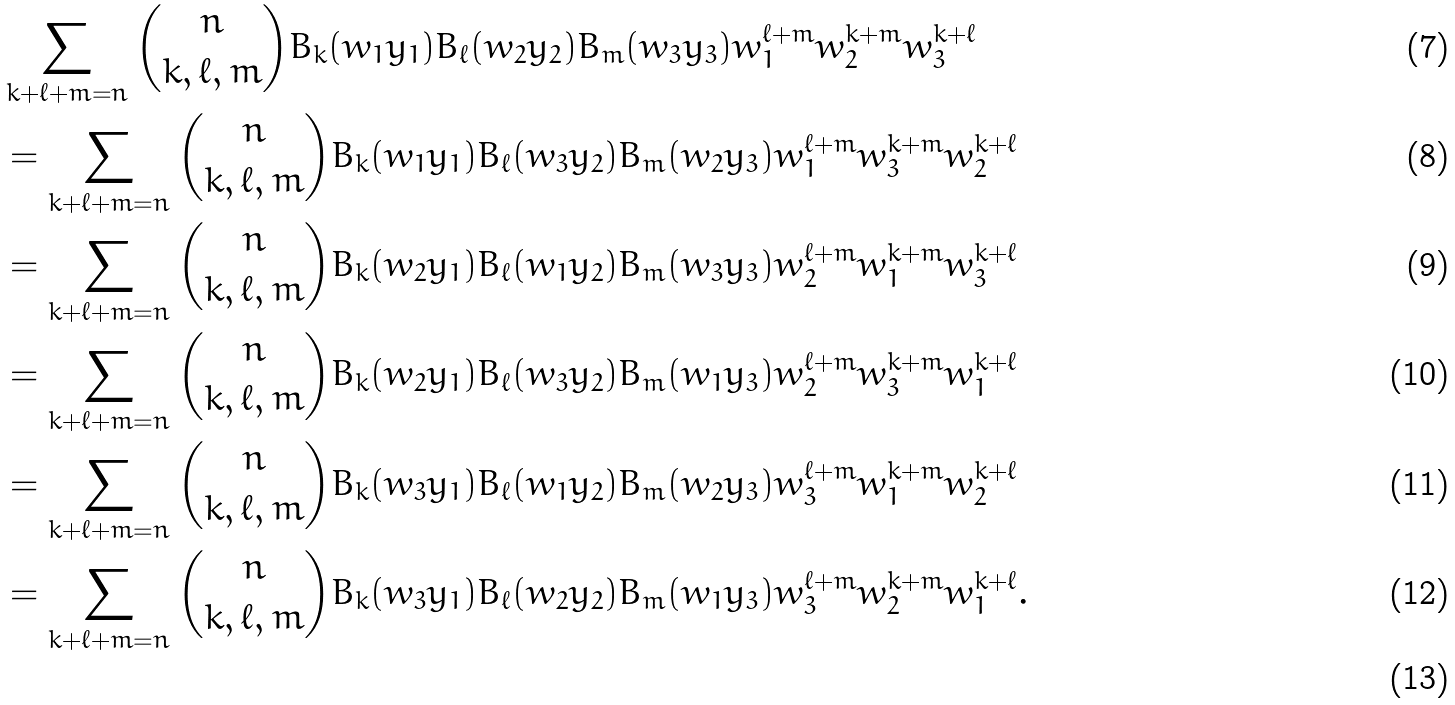Convert formula to latex. <formula><loc_0><loc_0><loc_500><loc_500>& \sum _ { k + \ell + m = n } \binom { n } { k , \ell , m } B _ { k } ( w _ { 1 } y _ { 1 } ) B _ { \ell } ( w _ { 2 } y _ { 2 } ) B _ { m } ( w _ { 3 } y _ { 3 } ) w _ { 1 } ^ { \ell + m } w _ { 2 } ^ { k + m } w _ { 3 } ^ { k + \ell } \\ & = \sum _ { k + \ell + m = n } \binom { n } { k , \ell , m } B _ { k } ( w _ { 1 } y _ { 1 } ) B _ { \ell } ( w _ { 3 } y _ { 2 } ) B _ { m } ( w _ { 2 } y _ { 3 } ) w _ { 1 } ^ { \ell + m } w _ { 3 } ^ { k + m } w _ { 2 } ^ { k + \ell } \\ & = \sum _ { k + \ell + m = n } \binom { n } { k , \ell , m } B _ { k } ( w _ { 2 } y _ { 1 } ) B _ { \ell } ( w _ { 1 } y _ { 2 } ) B _ { m } ( w _ { 3 } y _ { 3 } ) w _ { 2 } ^ { \ell + m } w _ { 1 } ^ { k + m } w _ { 3 } ^ { k + \ell } \\ & = \sum _ { k + \ell + m = n } \binom { n } { k , \ell , m } B _ { k } ( w _ { 2 } y _ { 1 } ) B _ { \ell } ( w _ { 3 } y _ { 2 } ) B _ { m } ( w _ { 1 } y _ { 3 } ) w _ { 2 } ^ { \ell + m } w _ { 3 } ^ { k + m } w _ { 1 } ^ { k + \ell } \\ & = \sum _ { k + \ell + m = n } \binom { n } { k , \ell , m } B _ { k } ( w _ { 3 } y _ { 1 } ) B _ { \ell } ( w _ { 1 } y _ { 2 } ) B _ { m } ( w _ { 2 } y _ { 3 } ) w _ { 3 } ^ { \ell + m } w _ { 1 } ^ { k + m } w _ { 2 } ^ { k + \ell } \\ & = \sum _ { k + \ell + m = n } \binom { n } { k , \ell , m } B _ { k } ( w _ { 3 } y _ { 1 } ) B _ { \ell } ( w _ { 2 } y _ { 2 } ) B _ { m } ( w _ { 1 } y _ { 3 } ) w _ { 3 } ^ { \ell + m } w _ { 2 } ^ { k + m } w _ { 1 } ^ { k + \ell } . \\</formula> 